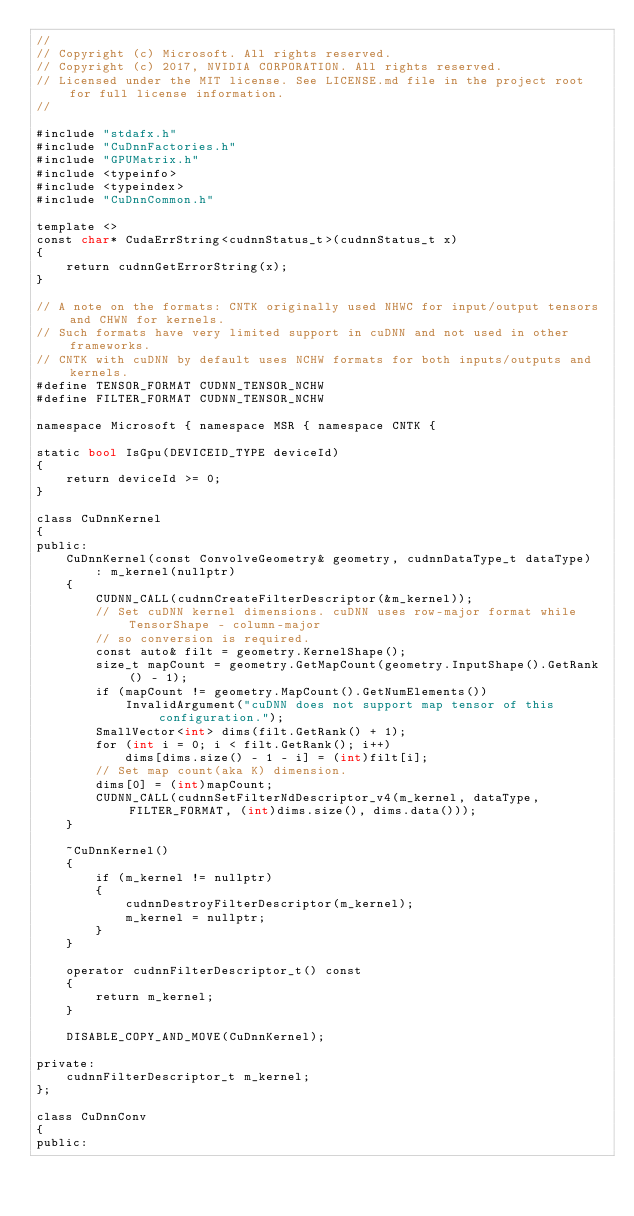<code> <loc_0><loc_0><loc_500><loc_500><_Cuda_>//
// Copyright (c) Microsoft. All rights reserved.
// Copyright (c) 2017, NVIDIA CORPORATION. All rights reserved.
// Licensed under the MIT license. See LICENSE.md file in the project root for full license information.
//

#include "stdafx.h"
#include "CuDnnFactories.h"
#include "GPUMatrix.h"
#include <typeinfo>
#include <typeindex>
#include "CuDnnCommon.h"

template <>
const char* CudaErrString<cudnnStatus_t>(cudnnStatus_t x)
{
    return cudnnGetErrorString(x);
}

// A note on the formats: CNTK originally used NHWC for input/output tensors and CHWN for kernels.
// Such formats have very limited support in cuDNN and not used in other frameworks.
// CNTK with cuDNN by default uses NCHW formats for both inputs/outputs and kernels.
#define TENSOR_FORMAT CUDNN_TENSOR_NCHW
#define FILTER_FORMAT CUDNN_TENSOR_NCHW

namespace Microsoft { namespace MSR { namespace CNTK {

static bool IsGpu(DEVICEID_TYPE deviceId)
{
    return deviceId >= 0;
}

class CuDnnKernel
{
public:
    CuDnnKernel(const ConvolveGeometry& geometry, cudnnDataType_t dataType)
        : m_kernel(nullptr)
    {
        CUDNN_CALL(cudnnCreateFilterDescriptor(&m_kernel));
        // Set cuDNN kernel dimensions. cuDNN uses row-major format while TensorShape - column-major
        // so conversion is required.
        const auto& filt = geometry.KernelShape();
        size_t mapCount = geometry.GetMapCount(geometry.InputShape().GetRank() - 1);
        if (mapCount != geometry.MapCount().GetNumElements())
            InvalidArgument("cuDNN does not support map tensor of this configuration.");
        SmallVector<int> dims(filt.GetRank() + 1);
        for (int i = 0; i < filt.GetRank(); i++)
            dims[dims.size() - 1 - i] = (int)filt[i];
        // Set map count(aka K) dimension.
        dims[0] = (int)mapCount;
        CUDNN_CALL(cudnnSetFilterNdDescriptor_v4(m_kernel, dataType, FILTER_FORMAT, (int)dims.size(), dims.data()));
    }

    ~CuDnnKernel()
    {
        if (m_kernel != nullptr)
        {
            cudnnDestroyFilterDescriptor(m_kernel);
            m_kernel = nullptr;
        }
    }

    operator cudnnFilterDescriptor_t() const
    {
        return m_kernel;
    }

    DISABLE_COPY_AND_MOVE(CuDnnKernel);

private:
    cudnnFilterDescriptor_t m_kernel;
};

class CuDnnConv
{
public:</code> 